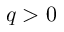<formula> <loc_0><loc_0><loc_500><loc_500>q > 0</formula> 